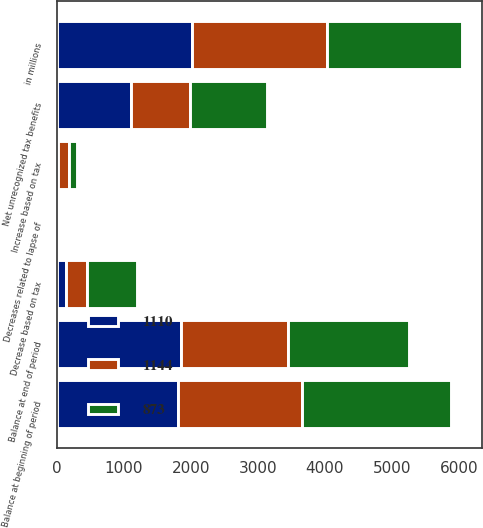Convert chart. <chart><loc_0><loc_0><loc_500><loc_500><stacked_bar_chart><ecel><fcel>in millions<fcel>Balance at beginning of period<fcel>Increase based on tax<fcel>Decrease based on tax<fcel>Decreases related to lapse of<fcel>Balance at end of period<fcel>Net unrecognized tax benefits<nl><fcel>1144<fcel>2017<fcel>1851<fcel>170<fcel>312<fcel>23<fcel>1594<fcel>873<nl><fcel>1110<fcel>2016<fcel>1804<fcel>14<fcel>134<fcel>5<fcel>1851<fcel>1110<nl><fcel>873<fcel>2015<fcel>2228<fcel>114<fcel>753<fcel>8<fcel>1804<fcel>1144<nl></chart> 